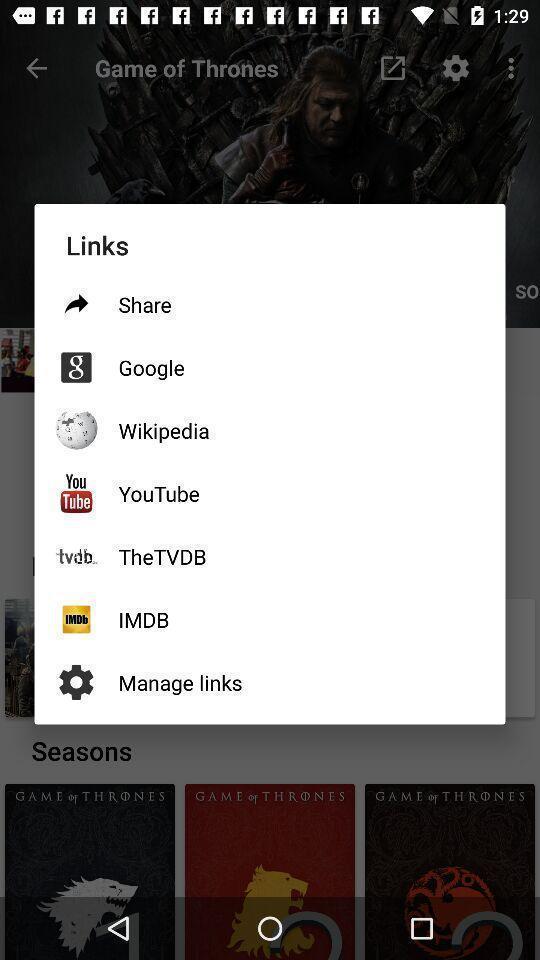What can you discern from this picture? Screen displays different links in app. 